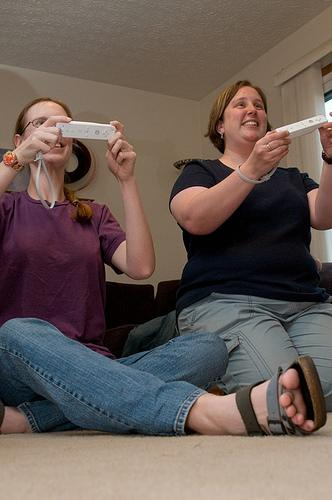What are these women looking at? tv screen 